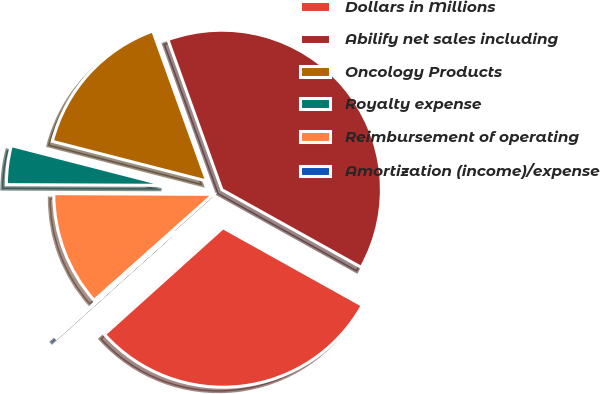Convert chart to OTSL. <chart><loc_0><loc_0><loc_500><loc_500><pie_chart><fcel>Dollars in Millions<fcel>Abilify net sales including<fcel>Oncology Products<fcel>Royalty expense<fcel>Reimbursement of operating<fcel>Amortization (income)/expense<nl><fcel>30.24%<fcel>38.59%<fcel>15.49%<fcel>3.94%<fcel>11.64%<fcel>0.09%<nl></chart> 